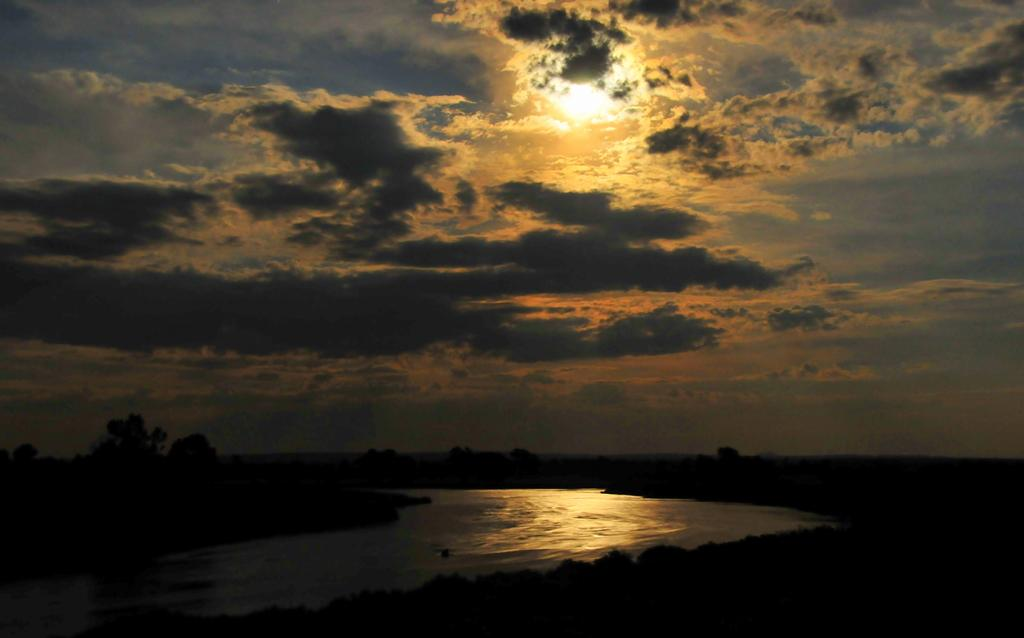What is visible in the image? Water is visible in the image. What type of vegetation can be seen in the image? There are trees in the image. What part of the natural environment is visible in the image? The sky is visible in the background of the image. What type of test can be seen being conducted in the water in the image? There is no test being conducted in the water in the image. What shape is the stew being served in the image? There is no stew present in the image. 